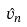Convert formula to latex. <formula><loc_0><loc_0><loc_500><loc_500>\hat { v } _ { n }</formula> 